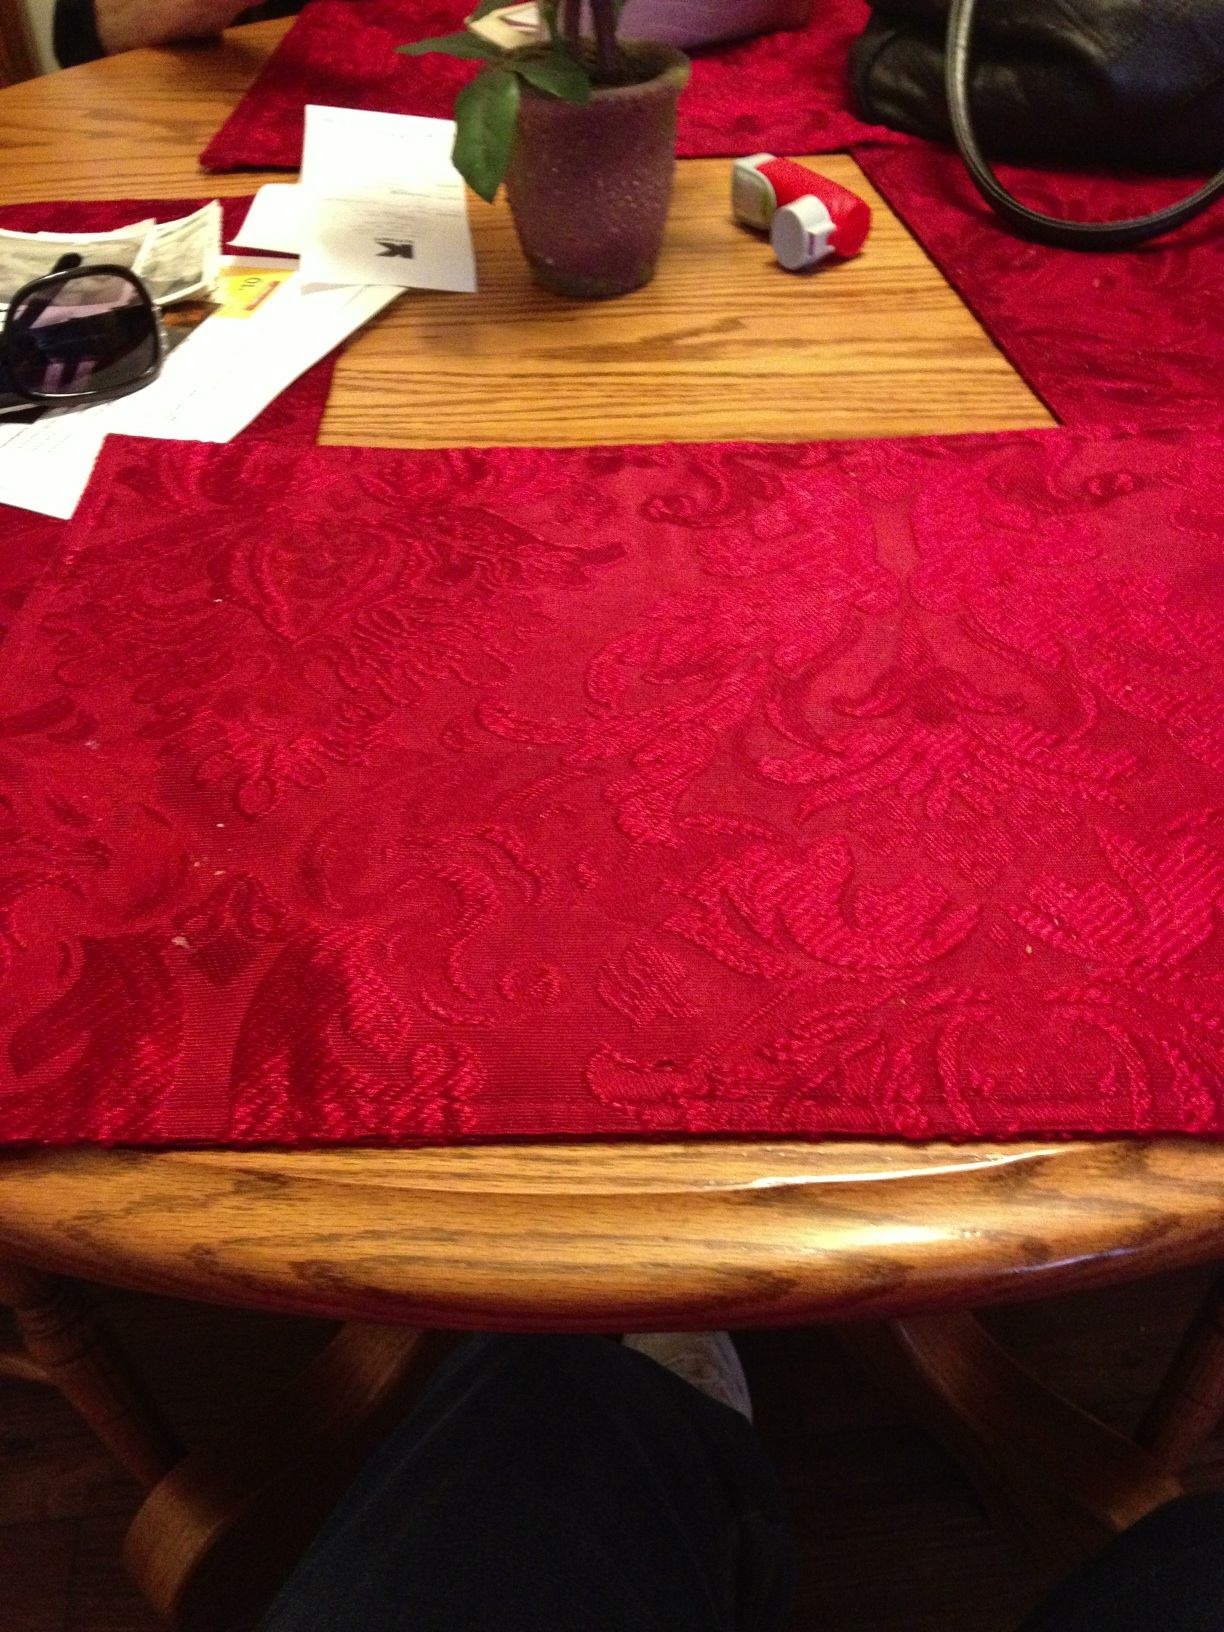What color is the mat? The mat in the image has a rich, burgundy color with intricate patterns, providing a warm and decorative accent to the wooden table. 